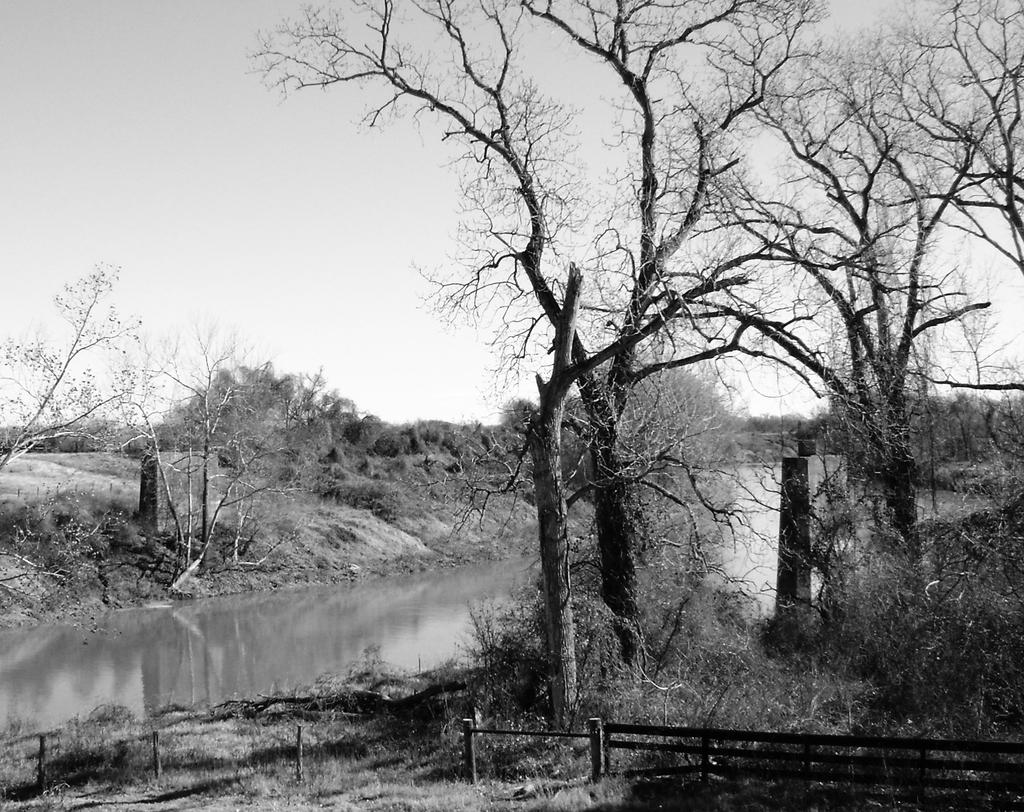What is the color scheme of the image? The image is in black and white. What natural feature can be seen in the image? There is a river in the image. What type of vegetation is present around the river? Trees, bushes, and plants are present around the river. What type of power can be seen flowing through the river in the image? There is no power visible in the image; it is a black and white depiction of a river with surrounding vegetation. 